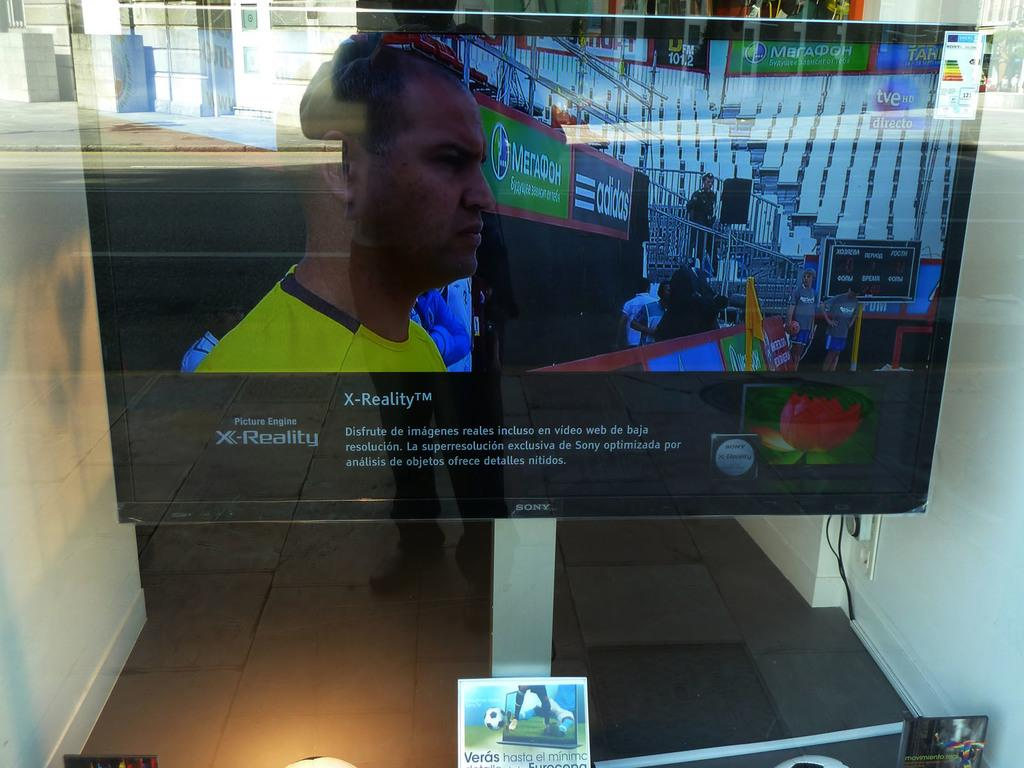<image>
Give a short and clear explanation of the subsequent image. A Sony TV displays an image using X-Reality. 